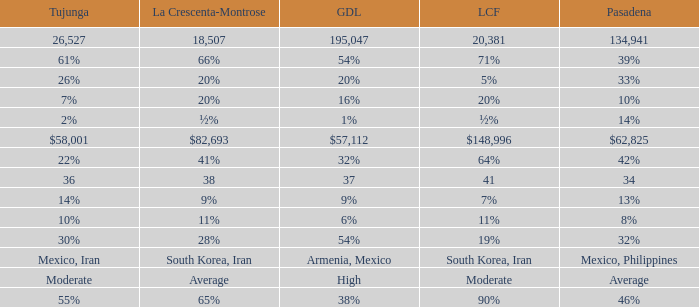Could you parse the entire table as a dict? {'header': ['Tujunga', 'La Crescenta-Montrose', 'GDL', 'LCF', 'Pasadena'], 'rows': [['26,527', '18,507', '195,047', '20,381', '134,941'], ['61%', '66%', '54%', '71%', '39%'], ['26%', '20%', '20%', '5%', '33%'], ['7%', '20%', '16%', '20%', '10%'], ['2%', '½%', '1%', '½%', '14%'], ['$58,001', '$82,693', '$57,112', '$148,996', '$62,825'], ['22%', '41%', '32%', '64%', '42%'], ['36', '38', '37', '41', '34'], ['14%', '9%', '9%', '7%', '13%'], ['10%', '11%', '6%', '11%', '8%'], ['30%', '28%', '54%', '19%', '32%'], ['Mexico, Iran', 'South Korea, Iran', 'Armenia, Mexico', 'South Korea, Iran', 'Mexico, Philippines'], ['Moderate', 'Average', 'High', 'Moderate', 'Average'], ['55%', '65%', '38%', '90%', '46%']]} What is the figure for Tujunga when Pasadena is 134,941? 26527.0. 